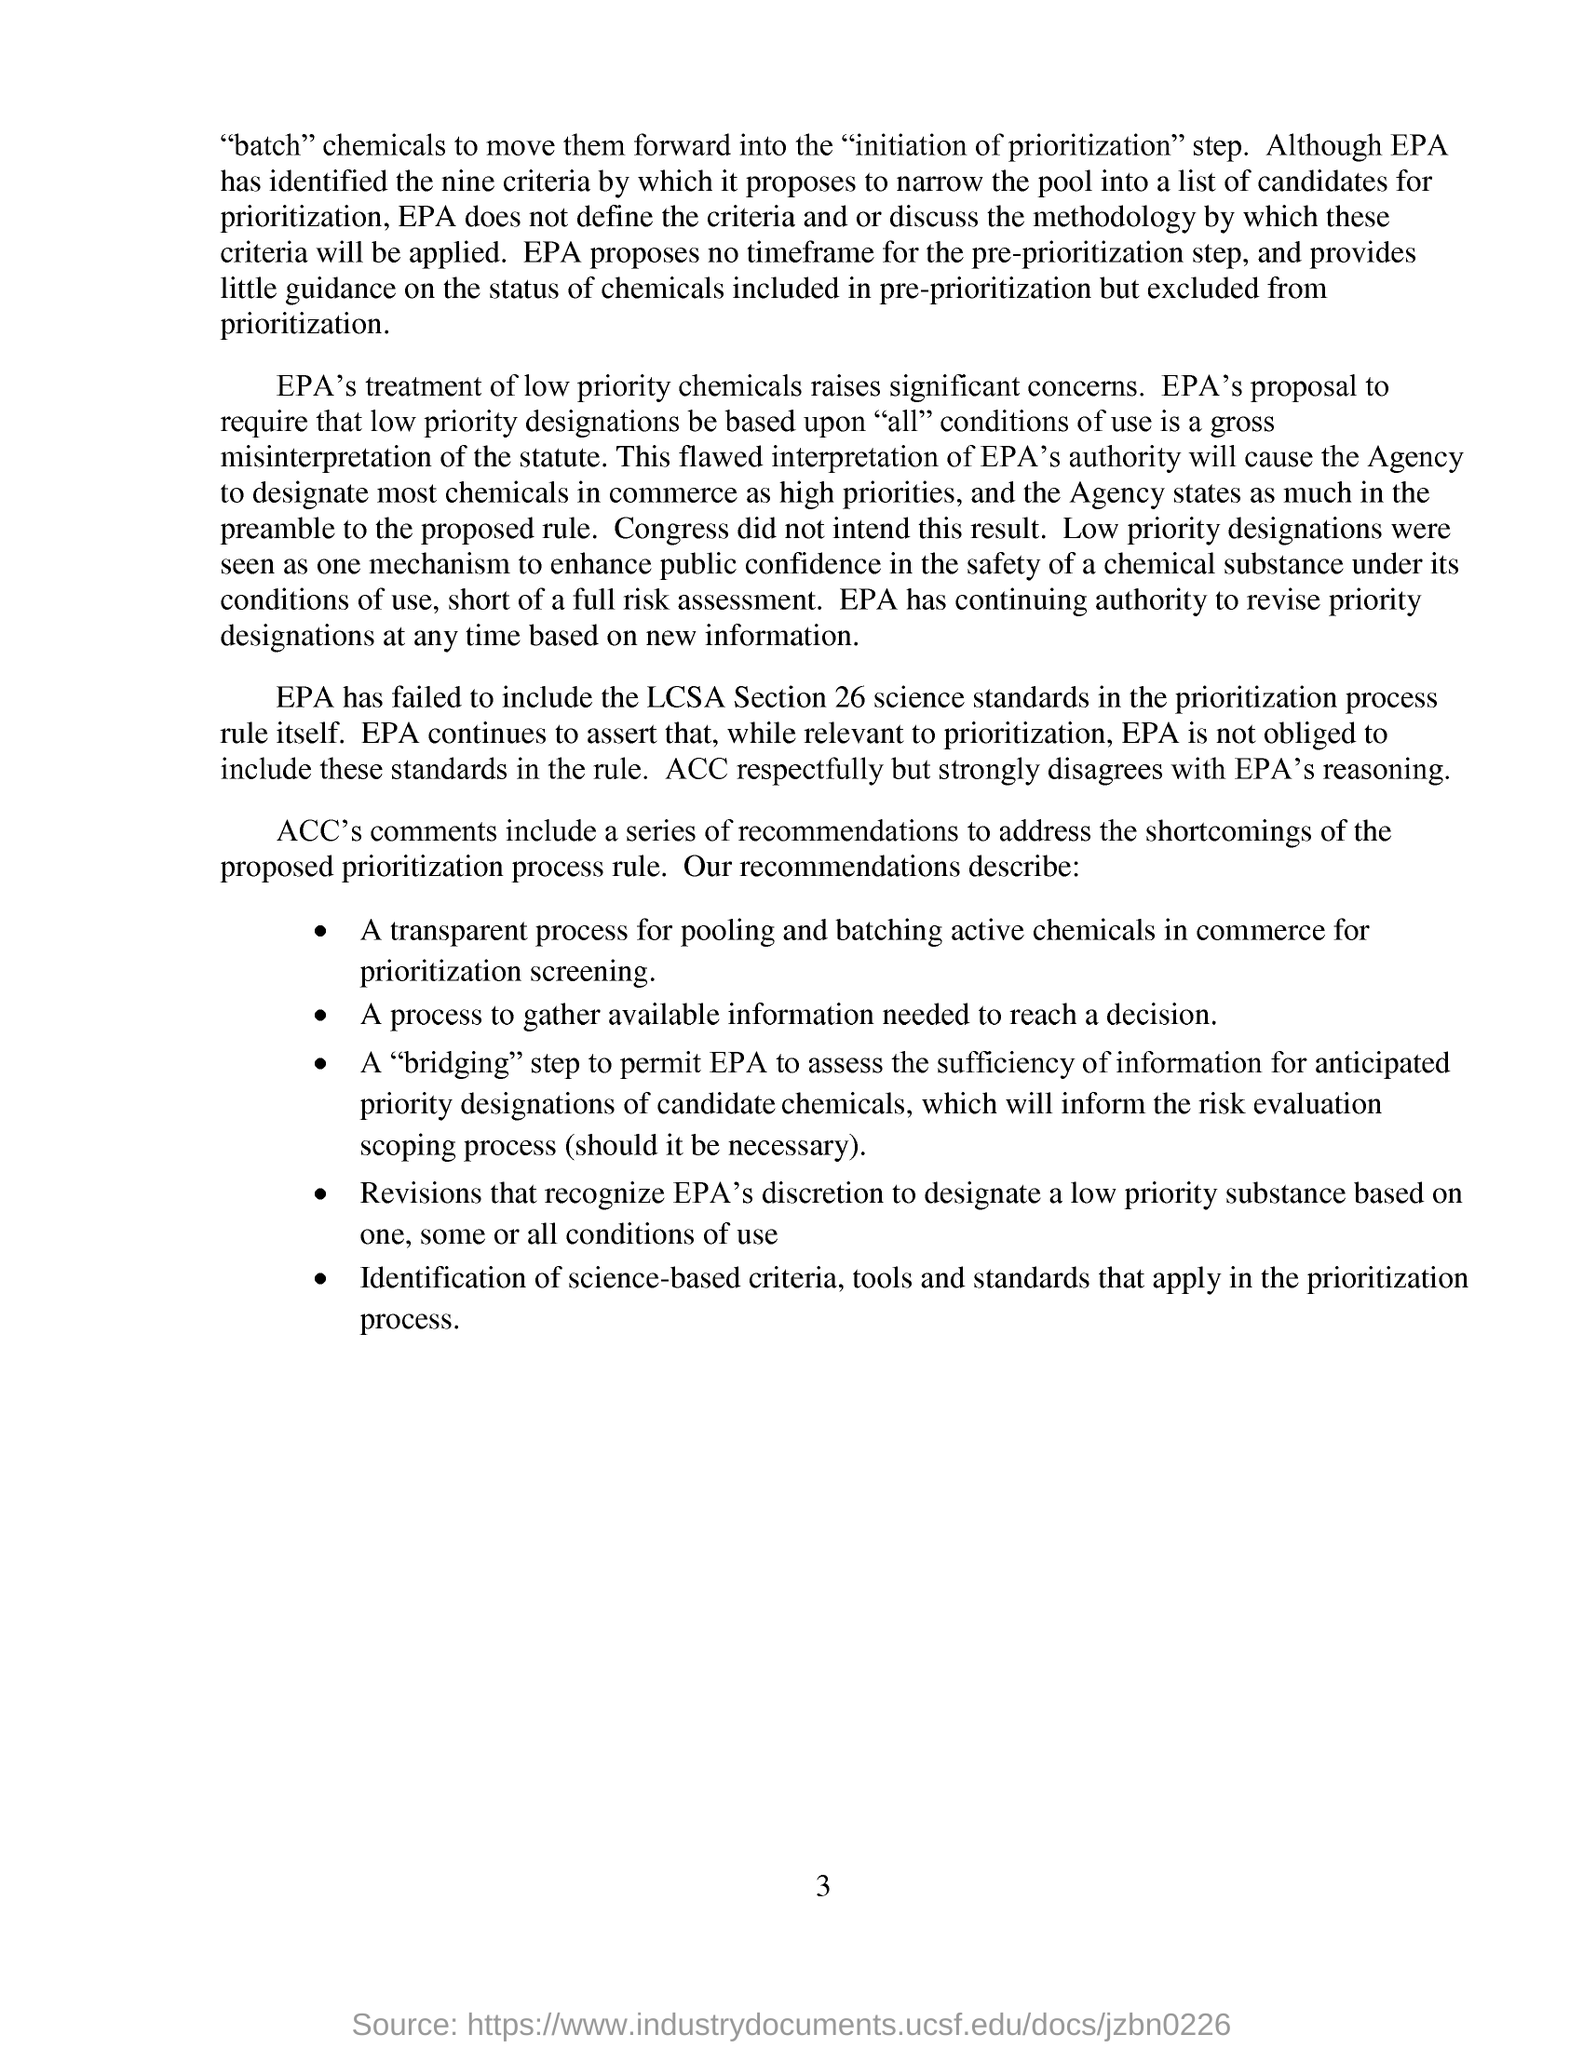EPA has failed to include which LCSA Section?
Give a very brief answer. Section 26. Who disagrees with EPA's reasoning?
Provide a succinct answer. ACC. 